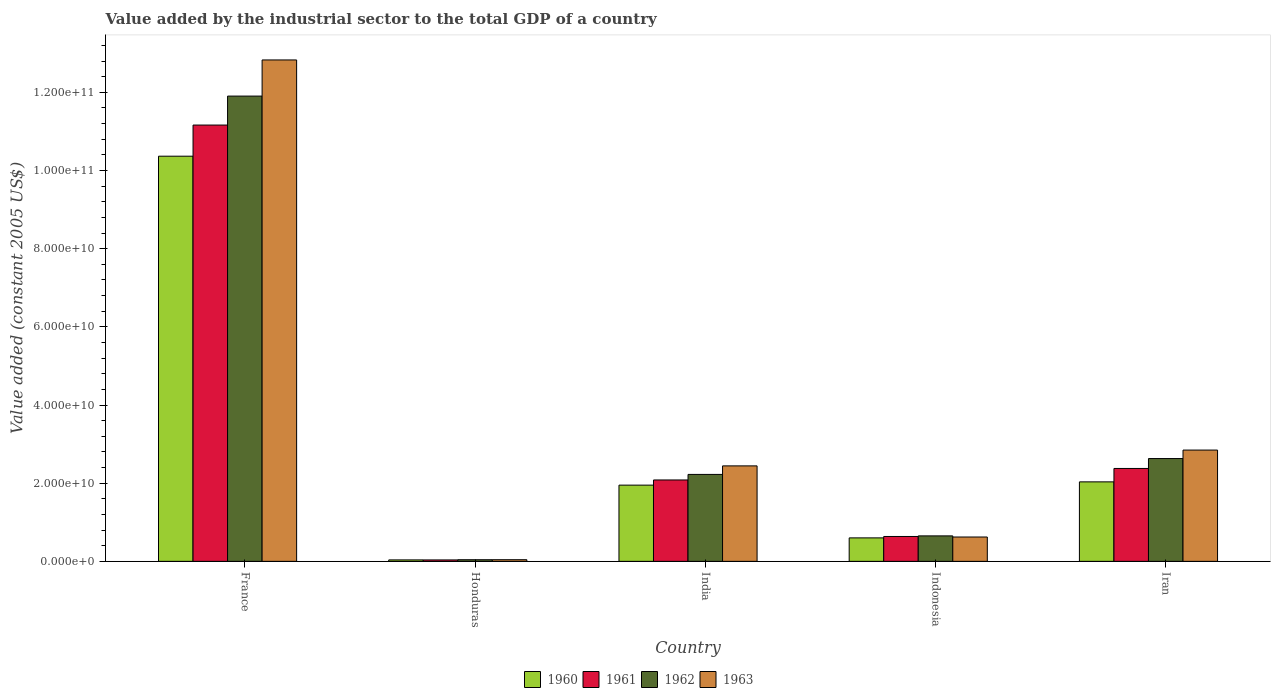How many groups of bars are there?
Your answer should be compact. 5. Are the number of bars per tick equal to the number of legend labels?
Provide a short and direct response. Yes. What is the label of the 5th group of bars from the left?
Offer a very short reply. Iran. What is the value added by the industrial sector in 1961 in Iran?
Your answer should be compact. 2.38e+1. Across all countries, what is the maximum value added by the industrial sector in 1961?
Provide a succinct answer. 1.12e+11. Across all countries, what is the minimum value added by the industrial sector in 1963?
Ensure brevity in your answer.  4.23e+08. In which country was the value added by the industrial sector in 1961 maximum?
Provide a succinct answer. France. In which country was the value added by the industrial sector in 1960 minimum?
Your response must be concise. Honduras. What is the total value added by the industrial sector in 1962 in the graph?
Offer a very short reply. 1.75e+11. What is the difference between the value added by the industrial sector in 1962 in Honduras and that in Iran?
Your answer should be very brief. -2.59e+1. What is the difference between the value added by the industrial sector in 1961 in Iran and the value added by the industrial sector in 1960 in Honduras?
Give a very brief answer. 2.34e+1. What is the average value added by the industrial sector in 1963 per country?
Provide a short and direct response. 3.76e+1. What is the difference between the value added by the industrial sector of/in 1960 and value added by the industrial sector of/in 1962 in Honduras?
Ensure brevity in your answer.  -4.07e+07. In how many countries, is the value added by the industrial sector in 1962 greater than 60000000000 US$?
Ensure brevity in your answer.  1. What is the ratio of the value added by the industrial sector in 1960 in India to that in Indonesia?
Your answer should be compact. 3.25. Is the difference between the value added by the industrial sector in 1960 in France and India greater than the difference between the value added by the industrial sector in 1962 in France and India?
Give a very brief answer. No. What is the difference between the highest and the second highest value added by the industrial sector in 1963?
Provide a succinct answer. -1.04e+11. What is the difference between the highest and the lowest value added by the industrial sector in 1960?
Your answer should be very brief. 1.03e+11. In how many countries, is the value added by the industrial sector in 1962 greater than the average value added by the industrial sector in 1962 taken over all countries?
Make the answer very short. 1. Is the sum of the value added by the industrial sector in 1962 in India and Iran greater than the maximum value added by the industrial sector in 1961 across all countries?
Keep it short and to the point. No. Are all the bars in the graph horizontal?
Your response must be concise. No. How many countries are there in the graph?
Your answer should be compact. 5. What is the difference between two consecutive major ticks on the Y-axis?
Your answer should be very brief. 2.00e+1. Are the values on the major ticks of Y-axis written in scientific E-notation?
Make the answer very short. Yes. Does the graph contain any zero values?
Your answer should be very brief. No. Does the graph contain grids?
Give a very brief answer. No. Where does the legend appear in the graph?
Keep it short and to the point. Bottom center. What is the title of the graph?
Your answer should be very brief. Value added by the industrial sector to the total GDP of a country. What is the label or title of the X-axis?
Your response must be concise. Country. What is the label or title of the Y-axis?
Your response must be concise. Value added (constant 2005 US$). What is the Value added (constant 2005 US$) of 1960 in France?
Keep it short and to the point. 1.04e+11. What is the Value added (constant 2005 US$) in 1961 in France?
Your response must be concise. 1.12e+11. What is the Value added (constant 2005 US$) in 1962 in France?
Ensure brevity in your answer.  1.19e+11. What is the Value added (constant 2005 US$) in 1963 in France?
Your response must be concise. 1.28e+11. What is the Value added (constant 2005 US$) in 1960 in Honduras?
Offer a terse response. 3.75e+08. What is the Value added (constant 2005 US$) of 1961 in Honduras?
Give a very brief answer. 3.66e+08. What is the Value added (constant 2005 US$) in 1962 in Honduras?
Your response must be concise. 4.16e+08. What is the Value added (constant 2005 US$) in 1963 in Honduras?
Provide a succinct answer. 4.23e+08. What is the Value added (constant 2005 US$) of 1960 in India?
Ensure brevity in your answer.  1.95e+1. What is the Value added (constant 2005 US$) of 1961 in India?
Your answer should be very brief. 2.08e+1. What is the Value added (constant 2005 US$) of 1962 in India?
Your answer should be compact. 2.22e+1. What is the Value added (constant 2005 US$) in 1963 in India?
Give a very brief answer. 2.44e+1. What is the Value added (constant 2005 US$) in 1960 in Indonesia?
Your answer should be very brief. 6.01e+09. What is the Value added (constant 2005 US$) of 1961 in Indonesia?
Make the answer very short. 6.37e+09. What is the Value added (constant 2005 US$) of 1962 in Indonesia?
Provide a succinct answer. 6.52e+09. What is the Value added (constant 2005 US$) of 1963 in Indonesia?
Provide a succinct answer. 6.23e+09. What is the Value added (constant 2005 US$) in 1960 in Iran?
Provide a succinct answer. 2.03e+1. What is the Value added (constant 2005 US$) in 1961 in Iran?
Provide a succinct answer. 2.38e+1. What is the Value added (constant 2005 US$) in 1962 in Iran?
Ensure brevity in your answer.  2.63e+1. What is the Value added (constant 2005 US$) of 1963 in Iran?
Offer a very short reply. 2.85e+1. Across all countries, what is the maximum Value added (constant 2005 US$) in 1960?
Keep it short and to the point. 1.04e+11. Across all countries, what is the maximum Value added (constant 2005 US$) of 1961?
Make the answer very short. 1.12e+11. Across all countries, what is the maximum Value added (constant 2005 US$) in 1962?
Offer a very short reply. 1.19e+11. Across all countries, what is the maximum Value added (constant 2005 US$) of 1963?
Your answer should be very brief. 1.28e+11. Across all countries, what is the minimum Value added (constant 2005 US$) of 1960?
Provide a succinct answer. 3.75e+08. Across all countries, what is the minimum Value added (constant 2005 US$) in 1961?
Offer a terse response. 3.66e+08. Across all countries, what is the minimum Value added (constant 2005 US$) of 1962?
Give a very brief answer. 4.16e+08. Across all countries, what is the minimum Value added (constant 2005 US$) in 1963?
Provide a short and direct response. 4.23e+08. What is the total Value added (constant 2005 US$) of 1960 in the graph?
Ensure brevity in your answer.  1.50e+11. What is the total Value added (constant 2005 US$) in 1961 in the graph?
Offer a very short reply. 1.63e+11. What is the total Value added (constant 2005 US$) in 1962 in the graph?
Keep it short and to the point. 1.75e+11. What is the total Value added (constant 2005 US$) of 1963 in the graph?
Your response must be concise. 1.88e+11. What is the difference between the Value added (constant 2005 US$) in 1960 in France and that in Honduras?
Provide a short and direct response. 1.03e+11. What is the difference between the Value added (constant 2005 US$) of 1961 in France and that in Honduras?
Offer a very short reply. 1.11e+11. What is the difference between the Value added (constant 2005 US$) in 1962 in France and that in Honduras?
Give a very brief answer. 1.19e+11. What is the difference between the Value added (constant 2005 US$) in 1963 in France and that in Honduras?
Your answer should be compact. 1.28e+11. What is the difference between the Value added (constant 2005 US$) of 1960 in France and that in India?
Ensure brevity in your answer.  8.42e+1. What is the difference between the Value added (constant 2005 US$) in 1961 in France and that in India?
Make the answer very short. 9.08e+1. What is the difference between the Value added (constant 2005 US$) in 1962 in France and that in India?
Ensure brevity in your answer.  9.68e+1. What is the difference between the Value added (constant 2005 US$) of 1963 in France and that in India?
Offer a terse response. 1.04e+11. What is the difference between the Value added (constant 2005 US$) of 1960 in France and that in Indonesia?
Provide a short and direct response. 9.77e+1. What is the difference between the Value added (constant 2005 US$) in 1961 in France and that in Indonesia?
Make the answer very short. 1.05e+11. What is the difference between the Value added (constant 2005 US$) in 1962 in France and that in Indonesia?
Offer a terse response. 1.13e+11. What is the difference between the Value added (constant 2005 US$) of 1963 in France and that in Indonesia?
Give a very brief answer. 1.22e+11. What is the difference between the Value added (constant 2005 US$) in 1960 in France and that in Iran?
Offer a very short reply. 8.33e+1. What is the difference between the Value added (constant 2005 US$) in 1961 in France and that in Iran?
Your answer should be very brief. 8.79e+1. What is the difference between the Value added (constant 2005 US$) of 1962 in France and that in Iran?
Ensure brevity in your answer.  9.27e+1. What is the difference between the Value added (constant 2005 US$) in 1963 in France and that in Iran?
Your answer should be very brief. 9.98e+1. What is the difference between the Value added (constant 2005 US$) in 1960 in Honduras and that in India?
Make the answer very short. -1.91e+1. What is the difference between the Value added (constant 2005 US$) in 1961 in Honduras and that in India?
Your response must be concise. -2.05e+1. What is the difference between the Value added (constant 2005 US$) in 1962 in Honduras and that in India?
Make the answer very short. -2.18e+1. What is the difference between the Value added (constant 2005 US$) in 1963 in Honduras and that in India?
Ensure brevity in your answer.  -2.40e+1. What is the difference between the Value added (constant 2005 US$) of 1960 in Honduras and that in Indonesia?
Ensure brevity in your answer.  -5.63e+09. What is the difference between the Value added (constant 2005 US$) in 1961 in Honduras and that in Indonesia?
Your response must be concise. -6.00e+09. What is the difference between the Value added (constant 2005 US$) of 1962 in Honduras and that in Indonesia?
Provide a short and direct response. -6.10e+09. What is the difference between the Value added (constant 2005 US$) in 1963 in Honduras and that in Indonesia?
Your answer should be very brief. -5.81e+09. What is the difference between the Value added (constant 2005 US$) in 1960 in Honduras and that in Iran?
Provide a succinct answer. -2.00e+1. What is the difference between the Value added (constant 2005 US$) in 1961 in Honduras and that in Iran?
Your answer should be very brief. -2.34e+1. What is the difference between the Value added (constant 2005 US$) in 1962 in Honduras and that in Iran?
Provide a short and direct response. -2.59e+1. What is the difference between the Value added (constant 2005 US$) in 1963 in Honduras and that in Iran?
Keep it short and to the point. -2.81e+1. What is the difference between the Value added (constant 2005 US$) of 1960 in India and that in Indonesia?
Your answer should be very brief. 1.35e+1. What is the difference between the Value added (constant 2005 US$) of 1961 in India and that in Indonesia?
Give a very brief answer. 1.45e+1. What is the difference between the Value added (constant 2005 US$) in 1962 in India and that in Indonesia?
Offer a terse response. 1.57e+1. What is the difference between the Value added (constant 2005 US$) of 1963 in India and that in Indonesia?
Make the answer very short. 1.82e+1. What is the difference between the Value added (constant 2005 US$) of 1960 in India and that in Iran?
Provide a succinct answer. -8.36e+08. What is the difference between the Value added (constant 2005 US$) in 1961 in India and that in Iran?
Give a very brief answer. -2.94e+09. What is the difference between the Value added (constant 2005 US$) of 1962 in India and that in Iran?
Offer a terse response. -4.06e+09. What is the difference between the Value added (constant 2005 US$) of 1963 in India and that in Iran?
Provide a succinct answer. -4.05e+09. What is the difference between the Value added (constant 2005 US$) of 1960 in Indonesia and that in Iran?
Keep it short and to the point. -1.43e+1. What is the difference between the Value added (constant 2005 US$) of 1961 in Indonesia and that in Iran?
Your answer should be very brief. -1.74e+1. What is the difference between the Value added (constant 2005 US$) in 1962 in Indonesia and that in Iran?
Keep it short and to the point. -1.98e+1. What is the difference between the Value added (constant 2005 US$) of 1963 in Indonesia and that in Iran?
Your response must be concise. -2.22e+1. What is the difference between the Value added (constant 2005 US$) in 1960 in France and the Value added (constant 2005 US$) in 1961 in Honduras?
Offer a terse response. 1.03e+11. What is the difference between the Value added (constant 2005 US$) in 1960 in France and the Value added (constant 2005 US$) in 1962 in Honduras?
Your answer should be very brief. 1.03e+11. What is the difference between the Value added (constant 2005 US$) of 1960 in France and the Value added (constant 2005 US$) of 1963 in Honduras?
Offer a terse response. 1.03e+11. What is the difference between the Value added (constant 2005 US$) of 1961 in France and the Value added (constant 2005 US$) of 1962 in Honduras?
Your response must be concise. 1.11e+11. What is the difference between the Value added (constant 2005 US$) in 1961 in France and the Value added (constant 2005 US$) in 1963 in Honduras?
Keep it short and to the point. 1.11e+11. What is the difference between the Value added (constant 2005 US$) in 1962 in France and the Value added (constant 2005 US$) in 1963 in Honduras?
Your answer should be very brief. 1.19e+11. What is the difference between the Value added (constant 2005 US$) in 1960 in France and the Value added (constant 2005 US$) in 1961 in India?
Keep it short and to the point. 8.28e+1. What is the difference between the Value added (constant 2005 US$) of 1960 in France and the Value added (constant 2005 US$) of 1962 in India?
Provide a short and direct response. 8.14e+1. What is the difference between the Value added (constant 2005 US$) in 1960 in France and the Value added (constant 2005 US$) in 1963 in India?
Your answer should be compact. 7.92e+1. What is the difference between the Value added (constant 2005 US$) in 1961 in France and the Value added (constant 2005 US$) in 1962 in India?
Provide a short and direct response. 8.94e+1. What is the difference between the Value added (constant 2005 US$) in 1961 in France and the Value added (constant 2005 US$) in 1963 in India?
Your answer should be compact. 8.72e+1. What is the difference between the Value added (constant 2005 US$) in 1962 in France and the Value added (constant 2005 US$) in 1963 in India?
Your response must be concise. 9.46e+1. What is the difference between the Value added (constant 2005 US$) of 1960 in France and the Value added (constant 2005 US$) of 1961 in Indonesia?
Provide a short and direct response. 9.73e+1. What is the difference between the Value added (constant 2005 US$) in 1960 in France and the Value added (constant 2005 US$) in 1962 in Indonesia?
Keep it short and to the point. 9.71e+1. What is the difference between the Value added (constant 2005 US$) of 1960 in France and the Value added (constant 2005 US$) of 1963 in Indonesia?
Ensure brevity in your answer.  9.74e+1. What is the difference between the Value added (constant 2005 US$) in 1961 in France and the Value added (constant 2005 US$) in 1962 in Indonesia?
Make the answer very short. 1.05e+11. What is the difference between the Value added (constant 2005 US$) in 1961 in France and the Value added (constant 2005 US$) in 1963 in Indonesia?
Your answer should be compact. 1.05e+11. What is the difference between the Value added (constant 2005 US$) in 1962 in France and the Value added (constant 2005 US$) in 1963 in Indonesia?
Make the answer very short. 1.13e+11. What is the difference between the Value added (constant 2005 US$) of 1960 in France and the Value added (constant 2005 US$) of 1961 in Iran?
Keep it short and to the point. 7.99e+1. What is the difference between the Value added (constant 2005 US$) of 1960 in France and the Value added (constant 2005 US$) of 1962 in Iran?
Make the answer very short. 7.74e+1. What is the difference between the Value added (constant 2005 US$) of 1960 in France and the Value added (constant 2005 US$) of 1963 in Iran?
Keep it short and to the point. 7.52e+1. What is the difference between the Value added (constant 2005 US$) in 1961 in France and the Value added (constant 2005 US$) in 1962 in Iran?
Provide a succinct answer. 8.53e+1. What is the difference between the Value added (constant 2005 US$) of 1961 in France and the Value added (constant 2005 US$) of 1963 in Iran?
Ensure brevity in your answer.  8.32e+1. What is the difference between the Value added (constant 2005 US$) in 1962 in France and the Value added (constant 2005 US$) in 1963 in Iran?
Your answer should be very brief. 9.06e+1. What is the difference between the Value added (constant 2005 US$) in 1960 in Honduras and the Value added (constant 2005 US$) in 1961 in India?
Offer a very short reply. -2.05e+1. What is the difference between the Value added (constant 2005 US$) of 1960 in Honduras and the Value added (constant 2005 US$) of 1962 in India?
Provide a succinct answer. -2.19e+1. What is the difference between the Value added (constant 2005 US$) in 1960 in Honduras and the Value added (constant 2005 US$) in 1963 in India?
Make the answer very short. -2.41e+1. What is the difference between the Value added (constant 2005 US$) of 1961 in Honduras and the Value added (constant 2005 US$) of 1962 in India?
Give a very brief answer. -2.19e+1. What is the difference between the Value added (constant 2005 US$) in 1961 in Honduras and the Value added (constant 2005 US$) in 1963 in India?
Your answer should be very brief. -2.41e+1. What is the difference between the Value added (constant 2005 US$) of 1962 in Honduras and the Value added (constant 2005 US$) of 1963 in India?
Your response must be concise. -2.40e+1. What is the difference between the Value added (constant 2005 US$) in 1960 in Honduras and the Value added (constant 2005 US$) in 1961 in Indonesia?
Make the answer very short. -5.99e+09. What is the difference between the Value added (constant 2005 US$) in 1960 in Honduras and the Value added (constant 2005 US$) in 1962 in Indonesia?
Offer a terse response. -6.14e+09. What is the difference between the Value added (constant 2005 US$) in 1960 in Honduras and the Value added (constant 2005 US$) in 1963 in Indonesia?
Provide a short and direct response. -5.85e+09. What is the difference between the Value added (constant 2005 US$) of 1961 in Honduras and the Value added (constant 2005 US$) of 1962 in Indonesia?
Your response must be concise. -6.15e+09. What is the difference between the Value added (constant 2005 US$) in 1961 in Honduras and the Value added (constant 2005 US$) in 1963 in Indonesia?
Your response must be concise. -5.86e+09. What is the difference between the Value added (constant 2005 US$) in 1962 in Honduras and the Value added (constant 2005 US$) in 1963 in Indonesia?
Ensure brevity in your answer.  -5.81e+09. What is the difference between the Value added (constant 2005 US$) of 1960 in Honduras and the Value added (constant 2005 US$) of 1961 in Iran?
Your answer should be compact. -2.34e+1. What is the difference between the Value added (constant 2005 US$) of 1960 in Honduras and the Value added (constant 2005 US$) of 1962 in Iran?
Make the answer very short. -2.59e+1. What is the difference between the Value added (constant 2005 US$) in 1960 in Honduras and the Value added (constant 2005 US$) in 1963 in Iran?
Keep it short and to the point. -2.81e+1. What is the difference between the Value added (constant 2005 US$) in 1961 in Honduras and the Value added (constant 2005 US$) in 1962 in Iran?
Offer a very short reply. -2.59e+1. What is the difference between the Value added (constant 2005 US$) in 1961 in Honduras and the Value added (constant 2005 US$) in 1963 in Iran?
Your answer should be very brief. -2.81e+1. What is the difference between the Value added (constant 2005 US$) of 1962 in Honduras and the Value added (constant 2005 US$) of 1963 in Iran?
Keep it short and to the point. -2.81e+1. What is the difference between the Value added (constant 2005 US$) in 1960 in India and the Value added (constant 2005 US$) in 1961 in Indonesia?
Provide a succinct answer. 1.31e+1. What is the difference between the Value added (constant 2005 US$) of 1960 in India and the Value added (constant 2005 US$) of 1962 in Indonesia?
Your answer should be very brief. 1.30e+1. What is the difference between the Value added (constant 2005 US$) in 1960 in India and the Value added (constant 2005 US$) in 1963 in Indonesia?
Provide a succinct answer. 1.33e+1. What is the difference between the Value added (constant 2005 US$) in 1961 in India and the Value added (constant 2005 US$) in 1962 in Indonesia?
Provide a short and direct response. 1.43e+1. What is the difference between the Value added (constant 2005 US$) of 1961 in India and the Value added (constant 2005 US$) of 1963 in Indonesia?
Keep it short and to the point. 1.46e+1. What is the difference between the Value added (constant 2005 US$) of 1962 in India and the Value added (constant 2005 US$) of 1963 in Indonesia?
Your response must be concise. 1.60e+1. What is the difference between the Value added (constant 2005 US$) of 1960 in India and the Value added (constant 2005 US$) of 1961 in Iran?
Keep it short and to the point. -4.27e+09. What is the difference between the Value added (constant 2005 US$) in 1960 in India and the Value added (constant 2005 US$) in 1962 in Iran?
Offer a terse response. -6.80e+09. What is the difference between the Value added (constant 2005 US$) in 1960 in India and the Value added (constant 2005 US$) in 1963 in Iran?
Your answer should be compact. -8.97e+09. What is the difference between the Value added (constant 2005 US$) of 1961 in India and the Value added (constant 2005 US$) of 1962 in Iran?
Give a very brief answer. -5.48e+09. What is the difference between the Value added (constant 2005 US$) of 1961 in India and the Value added (constant 2005 US$) of 1963 in Iran?
Make the answer very short. -7.65e+09. What is the difference between the Value added (constant 2005 US$) of 1962 in India and the Value added (constant 2005 US$) of 1963 in Iran?
Offer a terse response. -6.23e+09. What is the difference between the Value added (constant 2005 US$) of 1960 in Indonesia and the Value added (constant 2005 US$) of 1961 in Iran?
Offer a very short reply. -1.78e+1. What is the difference between the Value added (constant 2005 US$) in 1960 in Indonesia and the Value added (constant 2005 US$) in 1962 in Iran?
Keep it short and to the point. -2.03e+1. What is the difference between the Value added (constant 2005 US$) in 1960 in Indonesia and the Value added (constant 2005 US$) in 1963 in Iran?
Give a very brief answer. -2.25e+1. What is the difference between the Value added (constant 2005 US$) in 1961 in Indonesia and the Value added (constant 2005 US$) in 1962 in Iran?
Your answer should be compact. -1.99e+1. What is the difference between the Value added (constant 2005 US$) in 1961 in Indonesia and the Value added (constant 2005 US$) in 1963 in Iran?
Your response must be concise. -2.21e+1. What is the difference between the Value added (constant 2005 US$) in 1962 in Indonesia and the Value added (constant 2005 US$) in 1963 in Iran?
Give a very brief answer. -2.20e+1. What is the average Value added (constant 2005 US$) in 1960 per country?
Offer a terse response. 3.00e+1. What is the average Value added (constant 2005 US$) in 1961 per country?
Keep it short and to the point. 3.26e+1. What is the average Value added (constant 2005 US$) of 1962 per country?
Your response must be concise. 3.49e+1. What is the average Value added (constant 2005 US$) of 1963 per country?
Offer a terse response. 3.76e+1. What is the difference between the Value added (constant 2005 US$) of 1960 and Value added (constant 2005 US$) of 1961 in France?
Provide a succinct answer. -7.97e+09. What is the difference between the Value added (constant 2005 US$) in 1960 and Value added (constant 2005 US$) in 1962 in France?
Provide a short and direct response. -1.54e+1. What is the difference between the Value added (constant 2005 US$) in 1960 and Value added (constant 2005 US$) in 1963 in France?
Provide a succinct answer. -2.46e+1. What is the difference between the Value added (constant 2005 US$) of 1961 and Value added (constant 2005 US$) of 1962 in France?
Offer a terse response. -7.41e+09. What is the difference between the Value added (constant 2005 US$) of 1961 and Value added (constant 2005 US$) of 1963 in France?
Your answer should be very brief. -1.67e+1. What is the difference between the Value added (constant 2005 US$) of 1962 and Value added (constant 2005 US$) of 1963 in France?
Ensure brevity in your answer.  -9.25e+09. What is the difference between the Value added (constant 2005 US$) in 1960 and Value added (constant 2005 US$) in 1961 in Honduras?
Your response must be concise. 9.37e+06. What is the difference between the Value added (constant 2005 US$) of 1960 and Value added (constant 2005 US$) of 1962 in Honduras?
Your answer should be very brief. -4.07e+07. What is the difference between the Value added (constant 2005 US$) of 1960 and Value added (constant 2005 US$) of 1963 in Honduras?
Ensure brevity in your answer.  -4.79e+07. What is the difference between the Value added (constant 2005 US$) in 1961 and Value added (constant 2005 US$) in 1962 in Honduras?
Your answer should be very brief. -5.00e+07. What is the difference between the Value added (constant 2005 US$) of 1961 and Value added (constant 2005 US$) of 1963 in Honduras?
Give a very brief answer. -5.72e+07. What is the difference between the Value added (constant 2005 US$) in 1962 and Value added (constant 2005 US$) in 1963 in Honduras?
Your answer should be compact. -7.19e+06. What is the difference between the Value added (constant 2005 US$) of 1960 and Value added (constant 2005 US$) of 1961 in India?
Keep it short and to the point. -1.32e+09. What is the difference between the Value added (constant 2005 US$) in 1960 and Value added (constant 2005 US$) in 1962 in India?
Give a very brief answer. -2.74e+09. What is the difference between the Value added (constant 2005 US$) of 1960 and Value added (constant 2005 US$) of 1963 in India?
Make the answer very short. -4.92e+09. What is the difference between the Value added (constant 2005 US$) in 1961 and Value added (constant 2005 US$) in 1962 in India?
Your response must be concise. -1.42e+09. What is the difference between the Value added (constant 2005 US$) of 1961 and Value added (constant 2005 US$) of 1963 in India?
Your response must be concise. -3.60e+09. What is the difference between the Value added (constant 2005 US$) in 1962 and Value added (constant 2005 US$) in 1963 in India?
Your answer should be very brief. -2.18e+09. What is the difference between the Value added (constant 2005 US$) in 1960 and Value added (constant 2005 US$) in 1961 in Indonesia?
Keep it short and to the point. -3.60e+08. What is the difference between the Value added (constant 2005 US$) of 1960 and Value added (constant 2005 US$) of 1962 in Indonesia?
Your response must be concise. -5.10e+08. What is the difference between the Value added (constant 2005 US$) of 1960 and Value added (constant 2005 US$) of 1963 in Indonesia?
Your answer should be very brief. -2.22e+08. What is the difference between the Value added (constant 2005 US$) of 1961 and Value added (constant 2005 US$) of 1962 in Indonesia?
Keep it short and to the point. -1.50e+08. What is the difference between the Value added (constant 2005 US$) of 1961 and Value added (constant 2005 US$) of 1963 in Indonesia?
Provide a short and direct response. 1.38e+08. What is the difference between the Value added (constant 2005 US$) of 1962 and Value added (constant 2005 US$) of 1963 in Indonesia?
Offer a terse response. 2.88e+08. What is the difference between the Value added (constant 2005 US$) in 1960 and Value added (constant 2005 US$) in 1961 in Iran?
Give a very brief answer. -3.43e+09. What is the difference between the Value added (constant 2005 US$) in 1960 and Value added (constant 2005 US$) in 1962 in Iran?
Provide a short and direct response. -5.96e+09. What is the difference between the Value added (constant 2005 US$) in 1960 and Value added (constant 2005 US$) in 1963 in Iran?
Provide a short and direct response. -8.14e+09. What is the difference between the Value added (constant 2005 US$) in 1961 and Value added (constant 2005 US$) in 1962 in Iran?
Ensure brevity in your answer.  -2.53e+09. What is the difference between the Value added (constant 2005 US$) in 1961 and Value added (constant 2005 US$) in 1963 in Iran?
Your answer should be very brief. -4.71e+09. What is the difference between the Value added (constant 2005 US$) of 1962 and Value added (constant 2005 US$) of 1963 in Iran?
Provide a succinct answer. -2.17e+09. What is the ratio of the Value added (constant 2005 US$) in 1960 in France to that in Honduras?
Offer a terse response. 276.31. What is the ratio of the Value added (constant 2005 US$) in 1961 in France to that in Honduras?
Provide a short and direct response. 305.16. What is the ratio of the Value added (constant 2005 US$) of 1962 in France to that in Honduras?
Your response must be concise. 286.26. What is the ratio of the Value added (constant 2005 US$) of 1963 in France to that in Honduras?
Your response must be concise. 303.25. What is the ratio of the Value added (constant 2005 US$) of 1960 in France to that in India?
Make the answer very short. 5.32. What is the ratio of the Value added (constant 2005 US$) in 1961 in France to that in India?
Your answer should be very brief. 5.36. What is the ratio of the Value added (constant 2005 US$) of 1962 in France to that in India?
Provide a succinct answer. 5.35. What is the ratio of the Value added (constant 2005 US$) of 1963 in France to that in India?
Ensure brevity in your answer.  5.25. What is the ratio of the Value added (constant 2005 US$) in 1960 in France to that in Indonesia?
Provide a short and direct response. 17.26. What is the ratio of the Value added (constant 2005 US$) in 1961 in France to that in Indonesia?
Your answer should be very brief. 17.53. What is the ratio of the Value added (constant 2005 US$) in 1962 in France to that in Indonesia?
Offer a very short reply. 18.27. What is the ratio of the Value added (constant 2005 US$) in 1963 in France to that in Indonesia?
Your answer should be compact. 20.59. What is the ratio of the Value added (constant 2005 US$) in 1960 in France to that in Iran?
Provide a short and direct response. 5.1. What is the ratio of the Value added (constant 2005 US$) in 1961 in France to that in Iran?
Your answer should be compact. 4.7. What is the ratio of the Value added (constant 2005 US$) of 1962 in France to that in Iran?
Offer a very short reply. 4.53. What is the ratio of the Value added (constant 2005 US$) in 1963 in France to that in Iran?
Offer a very short reply. 4.51. What is the ratio of the Value added (constant 2005 US$) of 1960 in Honduras to that in India?
Offer a very short reply. 0.02. What is the ratio of the Value added (constant 2005 US$) in 1961 in Honduras to that in India?
Give a very brief answer. 0.02. What is the ratio of the Value added (constant 2005 US$) in 1962 in Honduras to that in India?
Offer a very short reply. 0.02. What is the ratio of the Value added (constant 2005 US$) in 1963 in Honduras to that in India?
Give a very brief answer. 0.02. What is the ratio of the Value added (constant 2005 US$) of 1960 in Honduras to that in Indonesia?
Your response must be concise. 0.06. What is the ratio of the Value added (constant 2005 US$) in 1961 in Honduras to that in Indonesia?
Keep it short and to the point. 0.06. What is the ratio of the Value added (constant 2005 US$) of 1962 in Honduras to that in Indonesia?
Make the answer very short. 0.06. What is the ratio of the Value added (constant 2005 US$) of 1963 in Honduras to that in Indonesia?
Make the answer very short. 0.07. What is the ratio of the Value added (constant 2005 US$) of 1960 in Honduras to that in Iran?
Provide a succinct answer. 0.02. What is the ratio of the Value added (constant 2005 US$) of 1961 in Honduras to that in Iran?
Provide a succinct answer. 0.02. What is the ratio of the Value added (constant 2005 US$) of 1962 in Honduras to that in Iran?
Provide a short and direct response. 0.02. What is the ratio of the Value added (constant 2005 US$) in 1963 in Honduras to that in Iran?
Give a very brief answer. 0.01. What is the ratio of the Value added (constant 2005 US$) in 1960 in India to that in Indonesia?
Provide a succinct answer. 3.25. What is the ratio of the Value added (constant 2005 US$) in 1961 in India to that in Indonesia?
Ensure brevity in your answer.  3.27. What is the ratio of the Value added (constant 2005 US$) of 1962 in India to that in Indonesia?
Your response must be concise. 3.41. What is the ratio of the Value added (constant 2005 US$) in 1963 in India to that in Indonesia?
Ensure brevity in your answer.  3.92. What is the ratio of the Value added (constant 2005 US$) of 1960 in India to that in Iran?
Make the answer very short. 0.96. What is the ratio of the Value added (constant 2005 US$) in 1961 in India to that in Iran?
Give a very brief answer. 0.88. What is the ratio of the Value added (constant 2005 US$) in 1962 in India to that in Iran?
Give a very brief answer. 0.85. What is the ratio of the Value added (constant 2005 US$) in 1963 in India to that in Iran?
Give a very brief answer. 0.86. What is the ratio of the Value added (constant 2005 US$) of 1960 in Indonesia to that in Iran?
Your answer should be very brief. 0.3. What is the ratio of the Value added (constant 2005 US$) of 1961 in Indonesia to that in Iran?
Keep it short and to the point. 0.27. What is the ratio of the Value added (constant 2005 US$) of 1962 in Indonesia to that in Iran?
Offer a terse response. 0.25. What is the ratio of the Value added (constant 2005 US$) in 1963 in Indonesia to that in Iran?
Your answer should be very brief. 0.22. What is the difference between the highest and the second highest Value added (constant 2005 US$) of 1960?
Ensure brevity in your answer.  8.33e+1. What is the difference between the highest and the second highest Value added (constant 2005 US$) in 1961?
Provide a short and direct response. 8.79e+1. What is the difference between the highest and the second highest Value added (constant 2005 US$) in 1962?
Your answer should be very brief. 9.27e+1. What is the difference between the highest and the second highest Value added (constant 2005 US$) in 1963?
Offer a terse response. 9.98e+1. What is the difference between the highest and the lowest Value added (constant 2005 US$) in 1960?
Your answer should be compact. 1.03e+11. What is the difference between the highest and the lowest Value added (constant 2005 US$) in 1961?
Provide a short and direct response. 1.11e+11. What is the difference between the highest and the lowest Value added (constant 2005 US$) of 1962?
Make the answer very short. 1.19e+11. What is the difference between the highest and the lowest Value added (constant 2005 US$) of 1963?
Your response must be concise. 1.28e+11. 